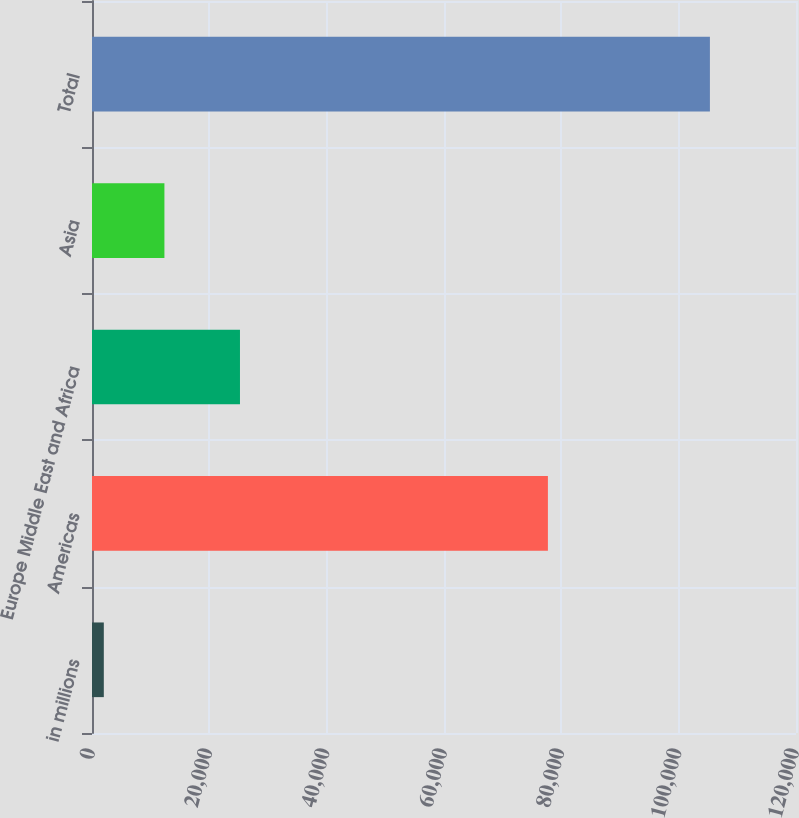Convert chart. <chart><loc_0><loc_0><loc_500><loc_500><bar_chart><fcel>in millions<fcel>Americas<fcel>Europe Middle East and Africa<fcel>Asia<fcel>Total<nl><fcel>2013<fcel>77710<fcel>25222<fcel>12344.2<fcel>105325<nl></chart> 